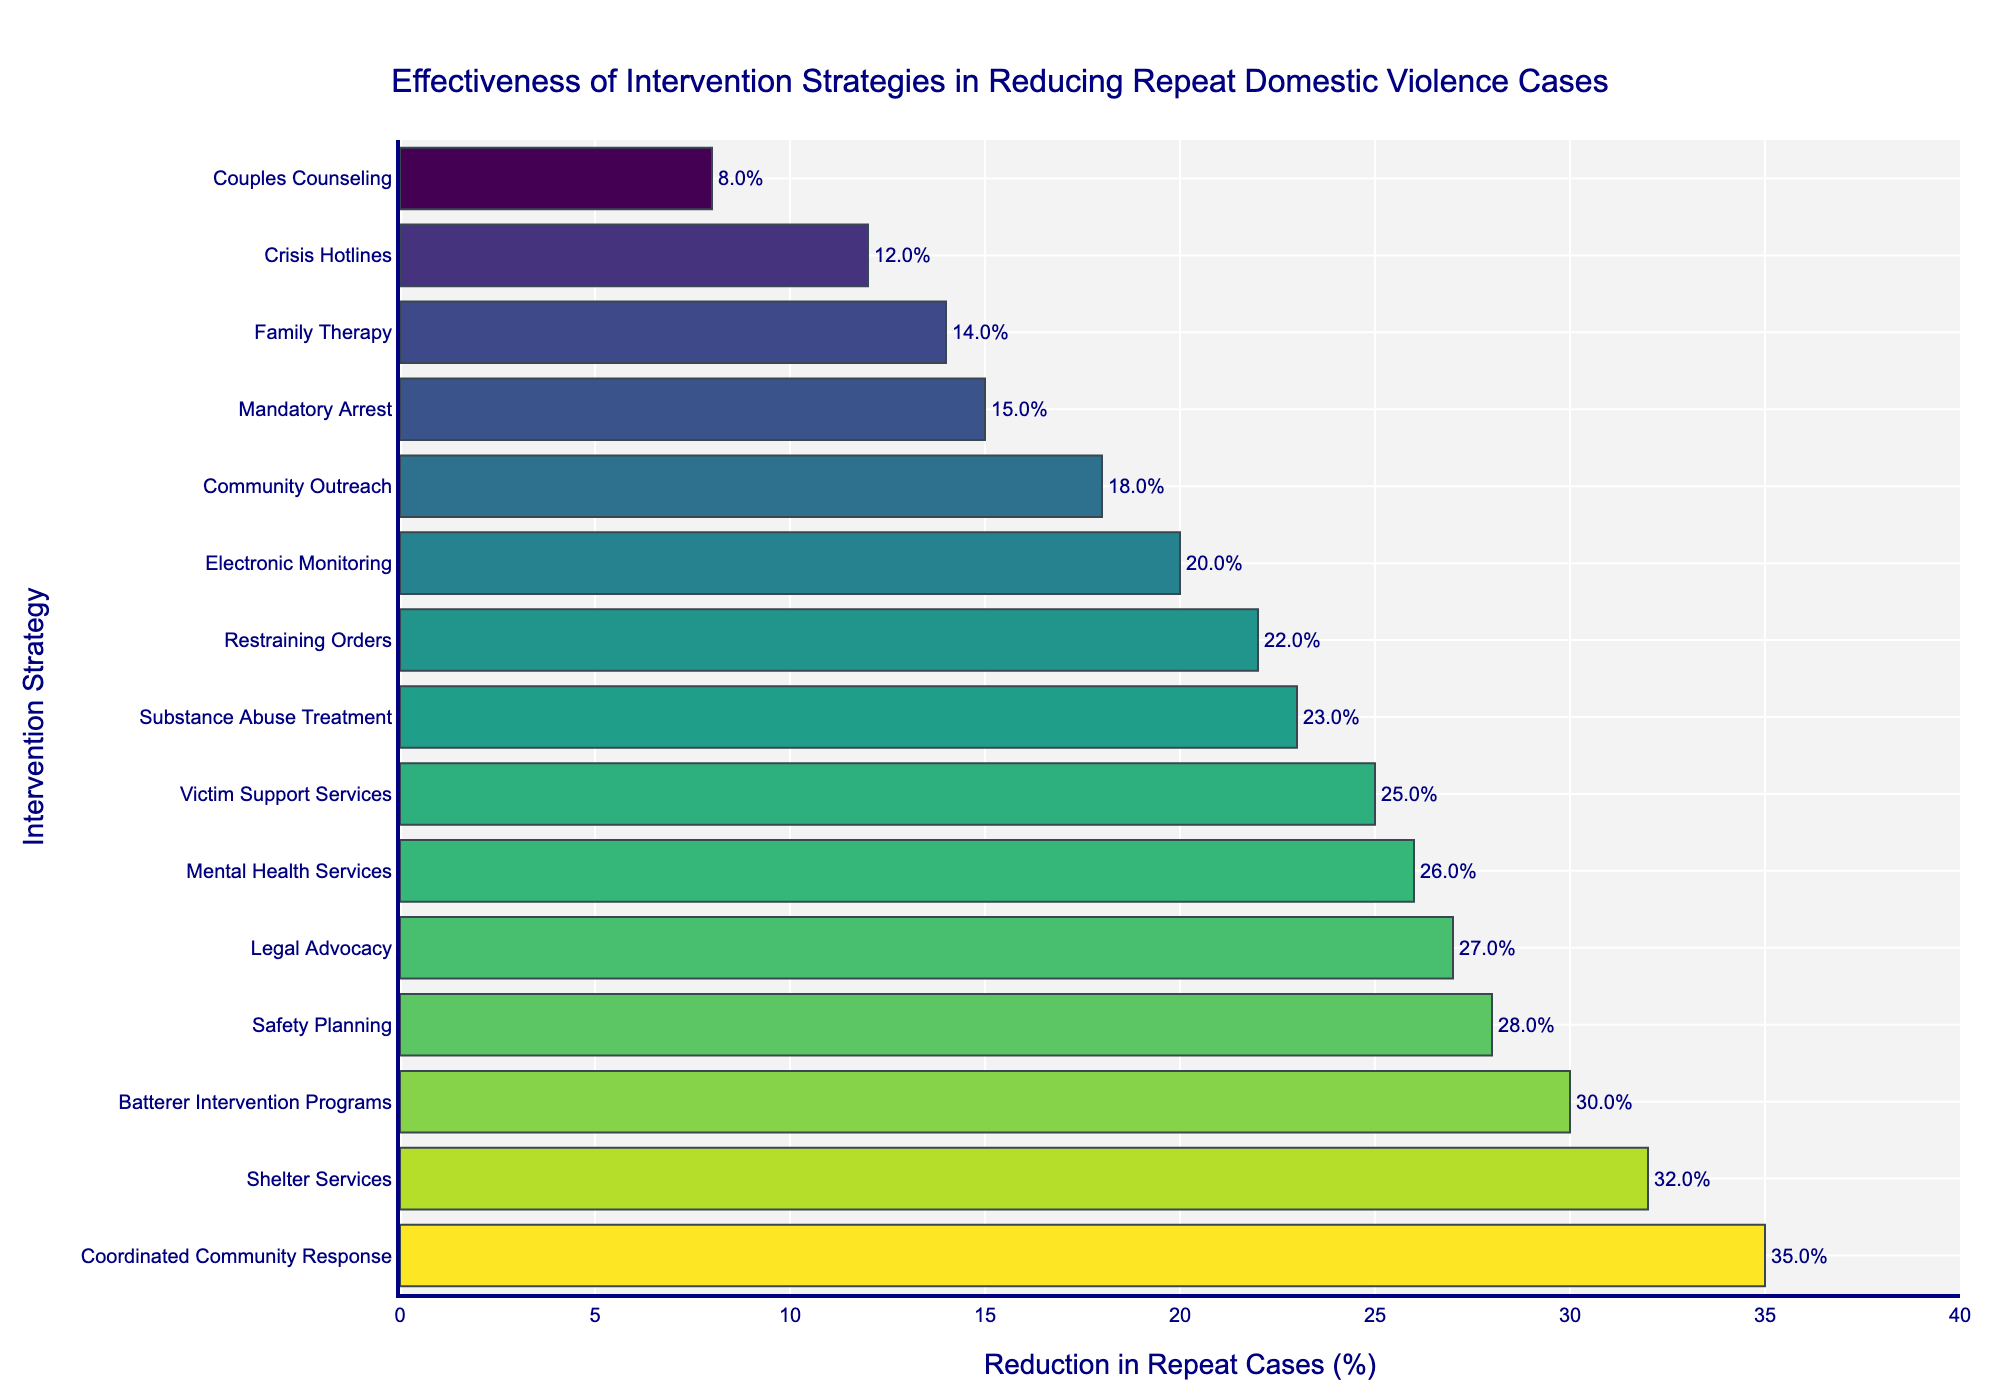Which intervention strategy has the highest reduction in repeat domestic violence cases? To find the intervention strategy with the highest reduction, look for the bar that is the longest. In this case, "Coordinated Community Response" is at the top with the longest bar.
Answer: Coordinated Community Response Which intervention strategy has the lowest reduction in repeat domestic violence cases? Identify the intervention strategy with the shortest bar, which represents the smallest percentage. "Couples Counseling" has the shortest bar.
Answer: Couples Counseling How much higher is the reduction percentage for "Shelter Services" compared to "Mandatory Arrest"? Find the bars for "Shelter Services" and "Mandatory Arrest". The reduction for "Shelter Services" is 32%, and for "Mandatory Arrest" it is 15%. Subtract these two values.
Answer: 17% What is the average reduction percentage of all the strategies listed? Add all the reduction percentages together and then divide by the number of strategies. The total sum of the percentages is 337. Divide this sum by 15 (the number of strategies).
Answer: 22.47% Which intervention strategies have a reduction percentage greater than 25%? Look for the bars that extend beyond the 25% mark on the x-axis. The strategies are "Batterer Intervention Programs", "Victim Support Services", "Safety Planning", "Shelter Services", "Legal Advocacy", and "Mental Health Services".
Answer: Batterer Intervention Programs, Victim Support Services, Safety Planning, Shelter Services, Legal Advocacy, Mental Health Services How much greater is the reduction percentage of the most effective strategy compared to the average reduction percentage? The most effective strategy is "Coordinated Community Response" with a 35% reduction. The average reduction percentage is 22.47%. Subtract the average from 35%.
Answer: 12.53% Which intervention strategies have a reduction percentage between 20% and 30%? Identify the bars that fall between the 20% and 30% range on the x-axis. The strategies are "Restraining Orders", "Victim Support Services", "Electronic Monitoring", "Substance Abuse Treatment", "Mental Health Services", and "Legal Advocacy".
Answer: Restraining Orders, Victim Support Services, Electronic Monitoring, Substance Abuse Treatment, Mental Health Services, Legal Advocacy What is the difference in reduction percentages between "Safety Planning" and "Crisis Hotlines"? Find the bars for "Safety Planning" (28%) and "Crisis Hotlines" (12%). Subtract the reduction percentage of "Crisis Hotlines" from that of "Safety Planning".
Answer: 16% Which intervention strategies have nearly the same reduction percentage? Look for the bars that have nearly the same length. "Substance Abuse Treatment" (23%) and "Mental Health Services" (26%) are close, but "Victim Support Services" (25%) and "Restraint Orders" (22%) are closer.
Answer: Restraining Orders and Victim Support Services 